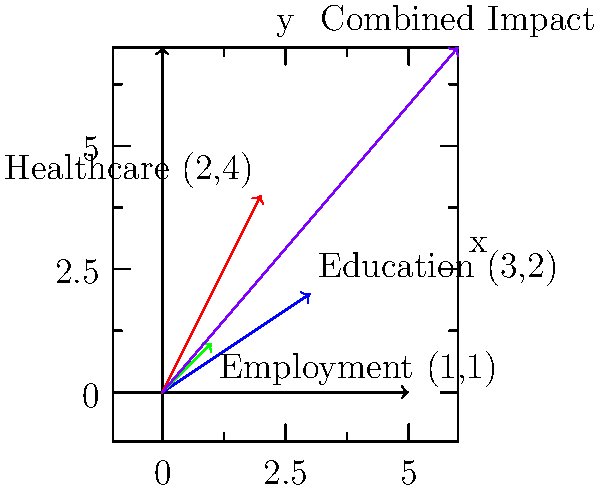A community is affected by three social factors: education, healthcare, and employment. These factors are represented as vectors in a 2D plane, where the x-axis represents the short-term impact and the y-axis represents the long-term impact. The vectors are:

Education: (3,2)
Healthcare: (2,4)
Employment: (1,1)

What is the combined impact of these three factors on the community, represented as a single vector? To find the combined impact of the three social factors, we need to perform vector addition. Here's how to do it step-by-step:

1. Identify the vectors:
   Education: $\vec{E} = (3,2)$
   Healthcare: $\vec{H} = (2,4)$
   Employment: $\vec{M} = (1,1)$

2. To add vectors, we add their corresponding components:
   $\vec{R} = \vec{E} + \vec{H} + \vec{M}$
   
   $\vec{R}_x = E_x + H_x + M_x = 3 + 2 + 1 = 6$
   $\vec{R}_y = E_y + H_y + M_y = 2 + 4 + 1 = 7$

3. The resulting vector is:
   $\vec{R} = (6,7)$

This vector represents the combined impact of education, healthcare, and employment on the community. The x-component (6) represents the total short-term impact, while the y-component (7) represents the total long-term impact.
Answer: $(6,7)$ 